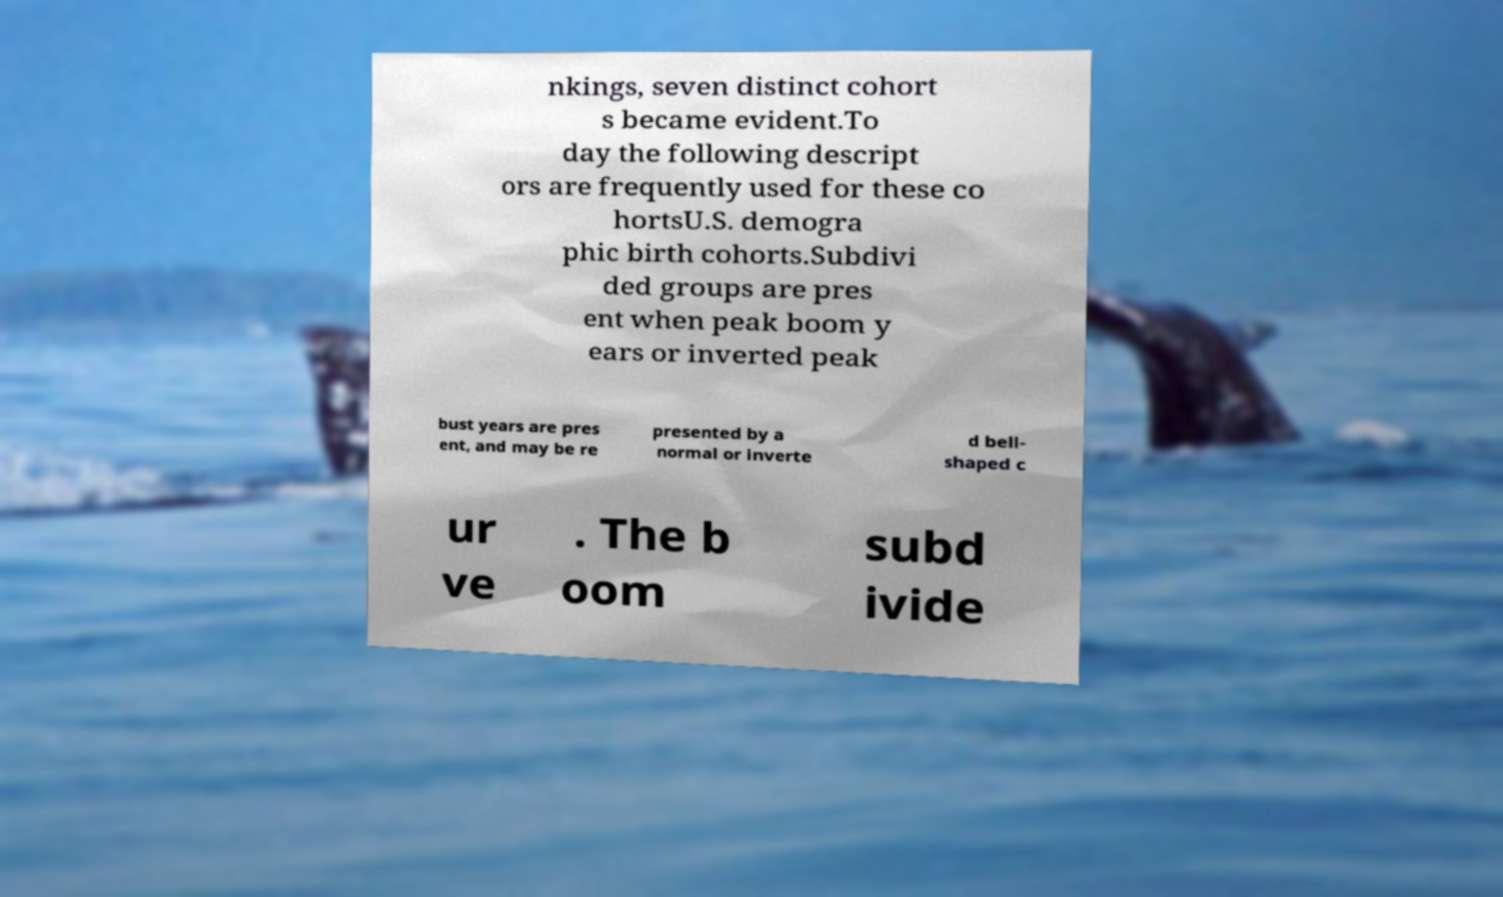Could you extract and type out the text from this image? nkings, seven distinct cohort s became evident.To day the following descript ors are frequently used for these co hortsU.S. demogra phic birth cohorts.Subdivi ded groups are pres ent when peak boom y ears or inverted peak bust years are pres ent, and may be re presented by a normal or inverte d bell- shaped c ur ve . The b oom subd ivide 